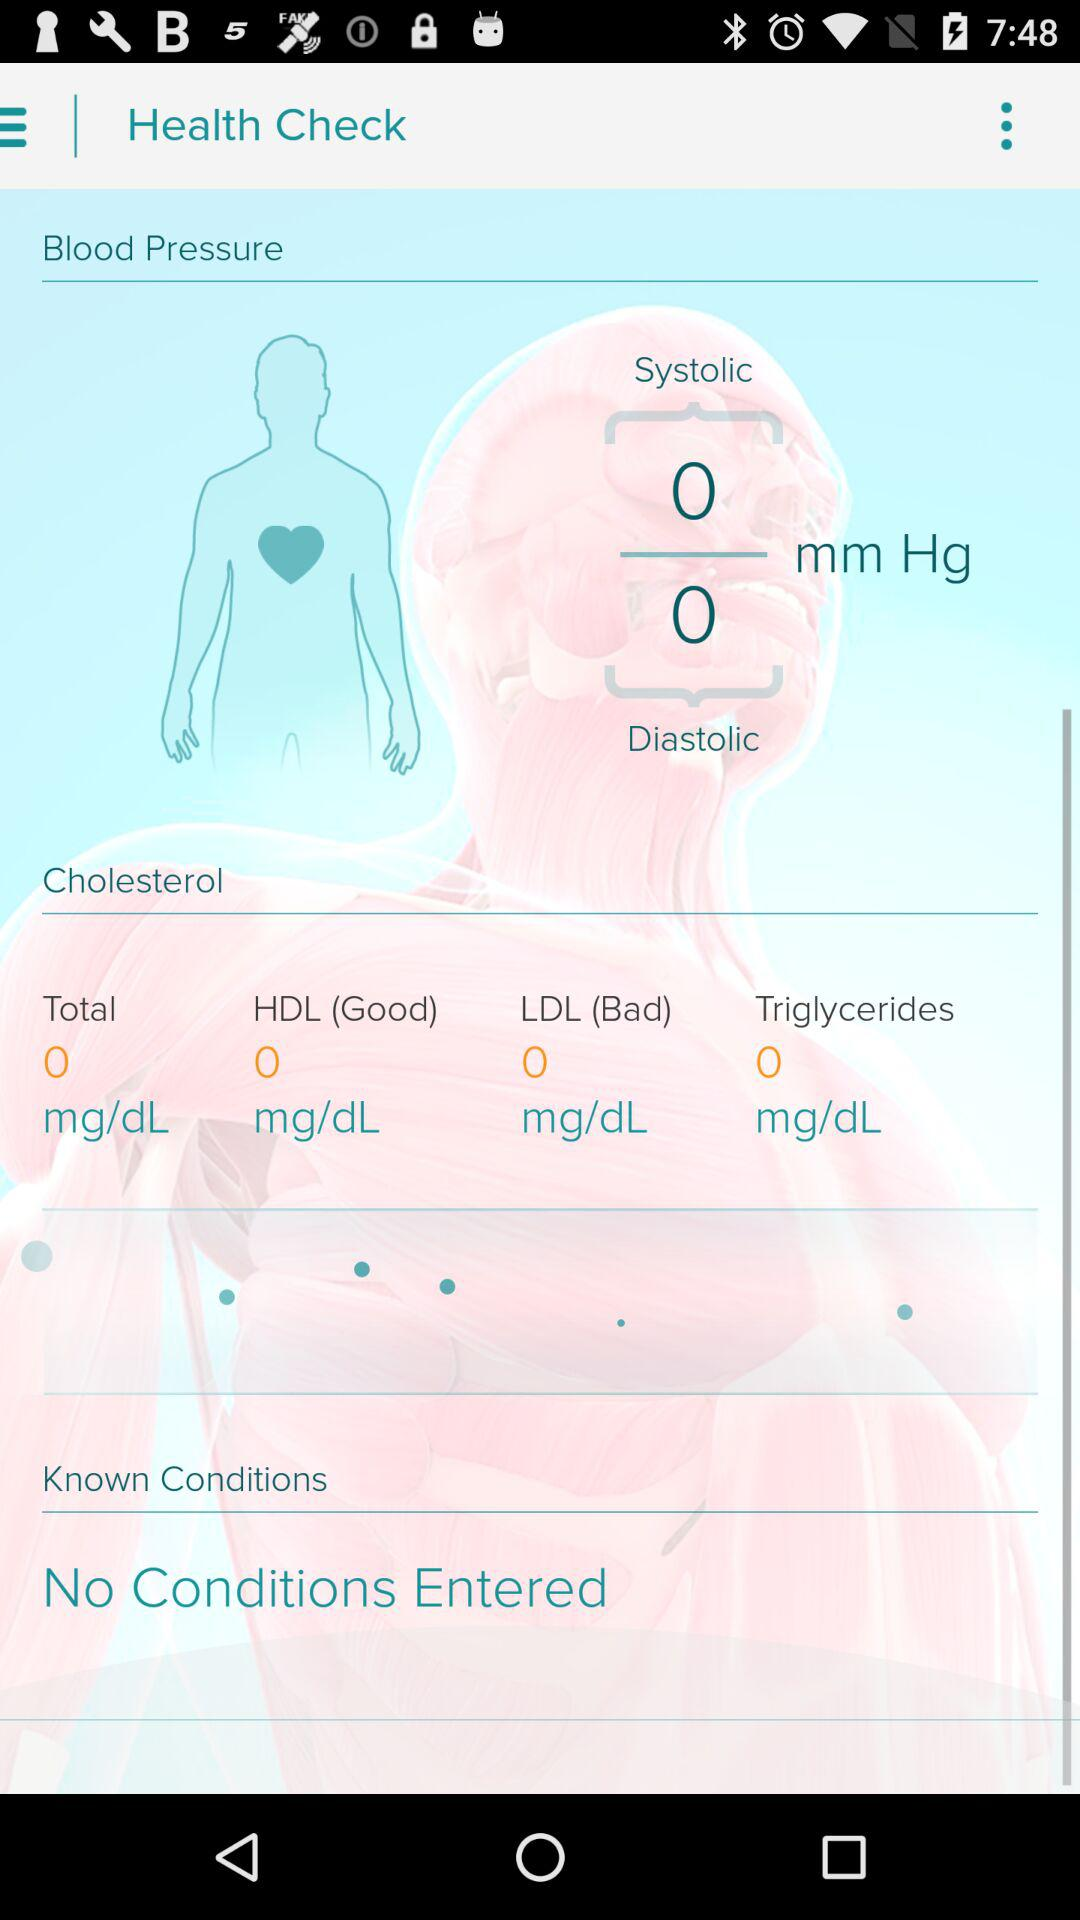What category of cholesterol is "Good"? The category of cholesterol that is "Good" is HDL. 